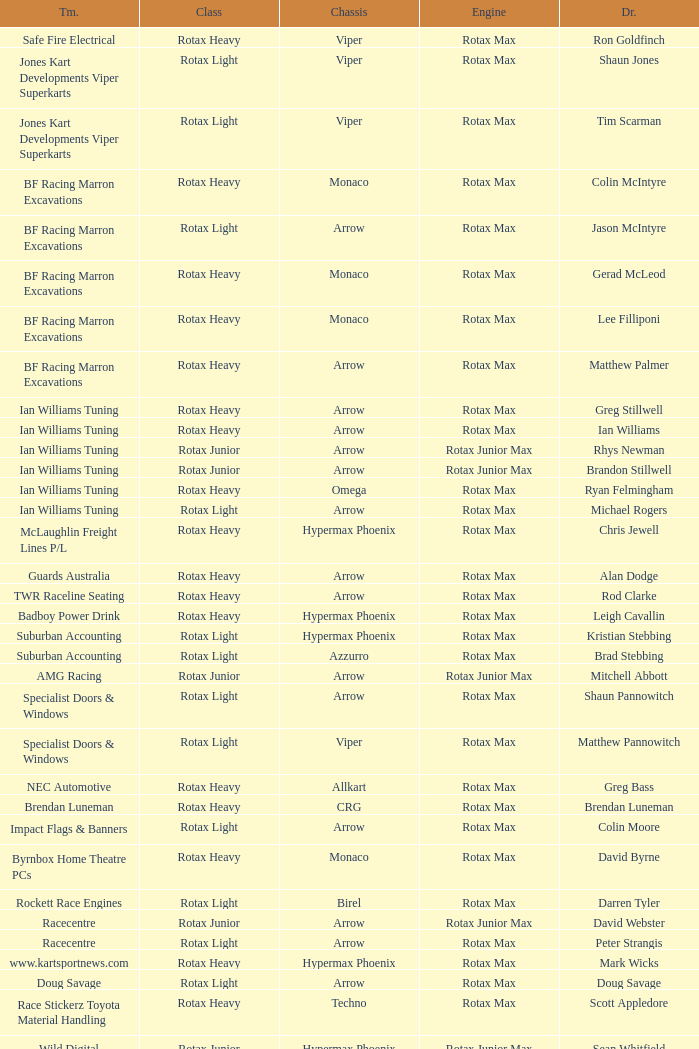Driver Shaun Jones with a viper as a chassis is in what class? Rotax Light. 